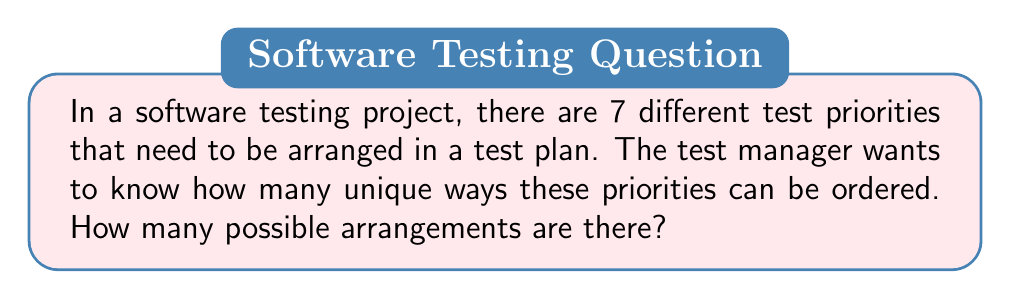Could you help me with this problem? To solve this problem, we need to use the concept of permutations. Since we are arranging all 7 test priorities and the order matters, this is a straightforward permutation problem.

The formula for permutations of n distinct objects is:

$$P(n) = n!$$

Where $n!$ represents the factorial of $n$.

In this case, $n = 7$ (the number of test priorities).

So, we calculate:

$$P(7) = 7!$$

$$7! = 7 \times 6 \times 5 \times 4 \times 3 \times 2 \times 1$$

$$7! = 5040$$

This means there are 5040 unique ways to arrange the 7 test priorities in the test plan.

For a software testing engineer, understanding this concept is crucial when designing test plans with multiple priorities. It highlights the importance of carefully considering the order of priorities, as there are many possible arrangements that could affect the testing process and outcomes.
Answer: $5040$ 